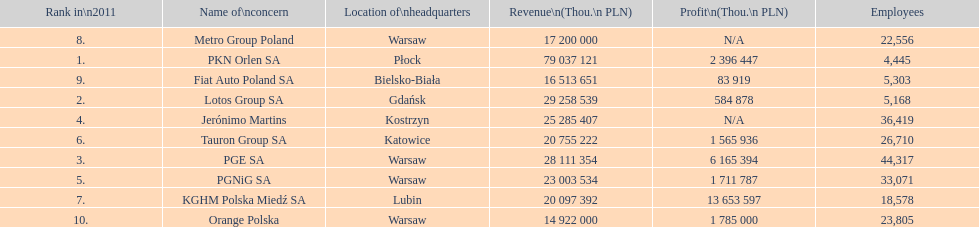Which company had the least revenue? Orange Polska. 